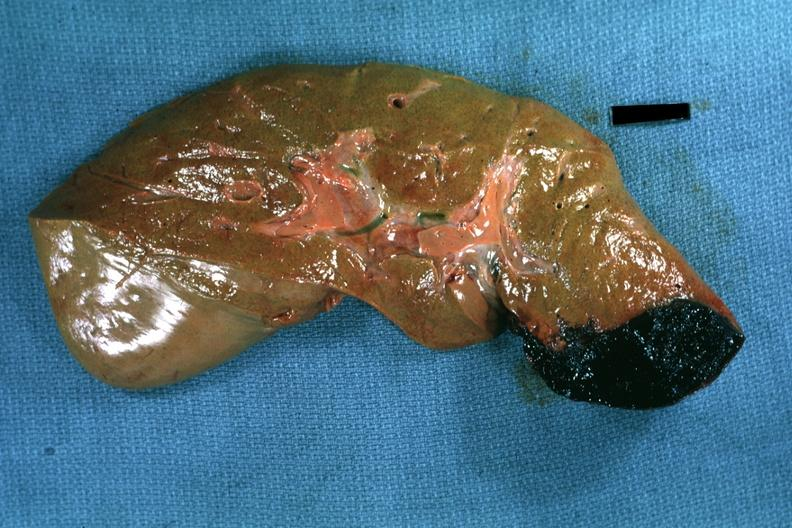what is present?
Answer the question using a single word or phrase. Liver 